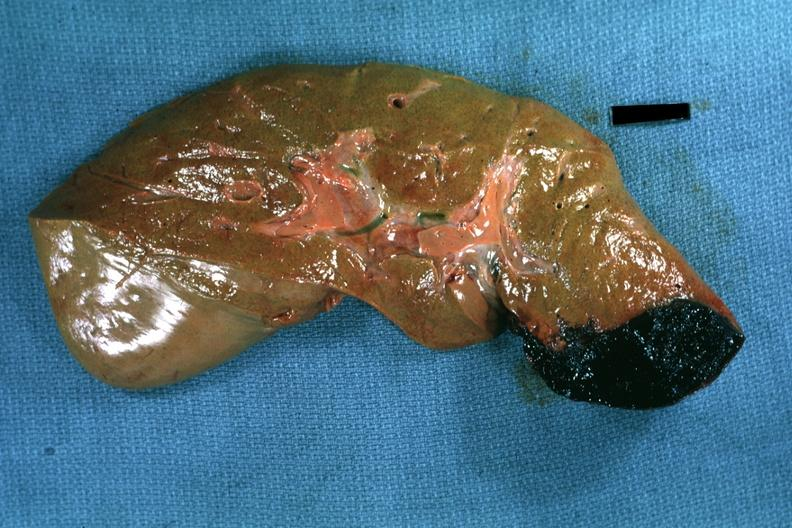what is present?
Answer the question using a single word or phrase. Liver 